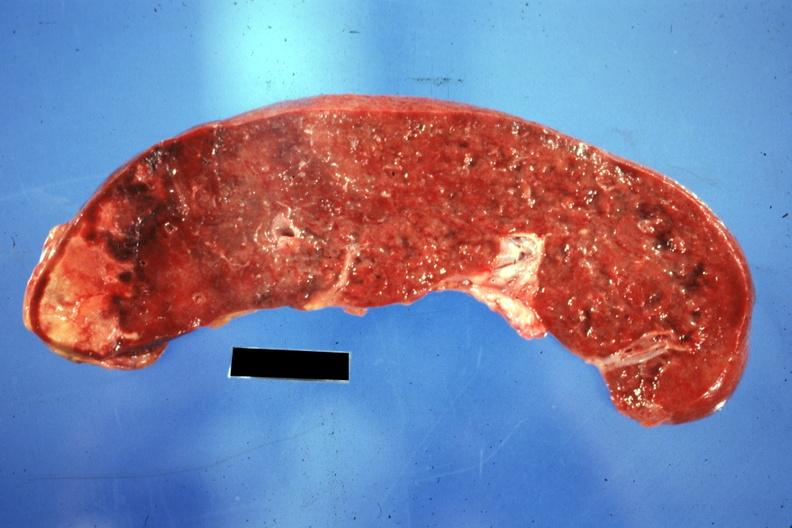what does this image show?
Answer the question using a single word or phrase. Cut surface of spleen with one large infarct classical embolus from nonbacterial endocarditis on mitral valve 